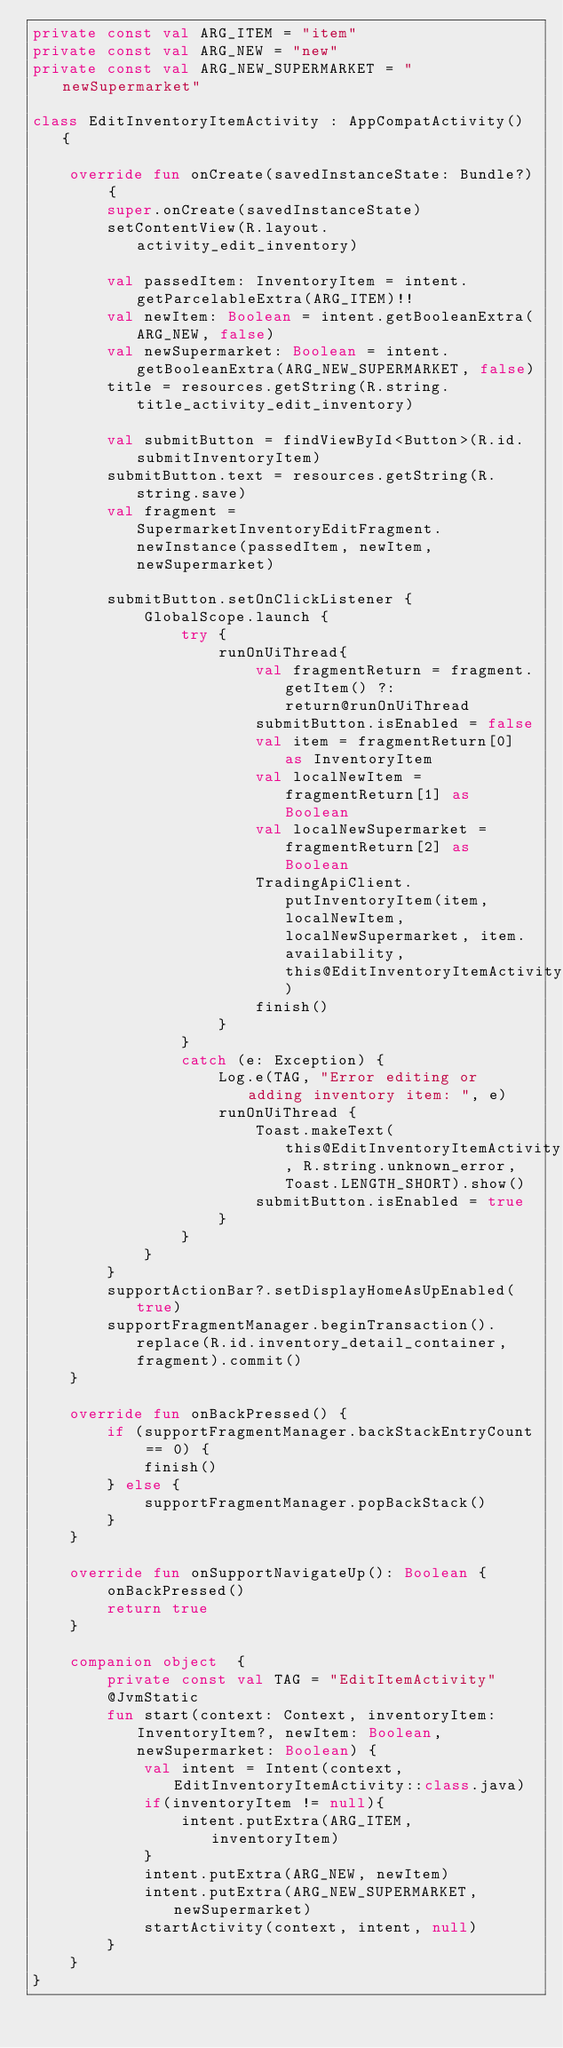Convert code to text. <code><loc_0><loc_0><loc_500><loc_500><_Kotlin_>private const val ARG_ITEM = "item"
private const val ARG_NEW = "new"
private const val ARG_NEW_SUPERMARKET = "newSupermarket"

class EditInventoryItemActivity : AppCompatActivity() {

    override fun onCreate(savedInstanceState: Bundle?) {
        super.onCreate(savedInstanceState)
        setContentView(R.layout.activity_edit_inventory)

        val passedItem: InventoryItem = intent.getParcelableExtra(ARG_ITEM)!!
        val newItem: Boolean = intent.getBooleanExtra(ARG_NEW, false)
        val newSupermarket: Boolean = intent.getBooleanExtra(ARG_NEW_SUPERMARKET, false)
        title = resources.getString(R.string.title_activity_edit_inventory)

        val submitButton = findViewById<Button>(R.id.submitInventoryItem)
        submitButton.text = resources.getString(R.string.save)
        val fragment = SupermarketInventoryEditFragment.newInstance(passedItem, newItem, newSupermarket)

        submitButton.setOnClickListener {
            GlobalScope.launch {
                try {
                    runOnUiThread{
                        val fragmentReturn = fragment.getItem() ?: return@runOnUiThread
                        submitButton.isEnabled = false
                        val item = fragmentReturn[0] as InventoryItem
                        val localNewItem = fragmentReturn[1] as Boolean
                        val localNewSupermarket = fragmentReturn[2] as Boolean
                        TradingApiClient.putInventoryItem(item, localNewItem, localNewSupermarket, item.availability, this@EditInventoryItemActivity)
                        finish()
                    }
                }
                catch (e: Exception) {
                    Log.e(TAG, "Error editing or adding inventory item: ", e)
                    runOnUiThread {
                        Toast.makeText(this@EditInventoryItemActivity, R.string.unknown_error, Toast.LENGTH_SHORT).show()
                        submitButton.isEnabled = true
                    }
                }
            }
        }
        supportActionBar?.setDisplayHomeAsUpEnabled(true)
        supportFragmentManager.beginTransaction().replace(R.id.inventory_detail_container, fragment).commit()
    }

    override fun onBackPressed() {
        if (supportFragmentManager.backStackEntryCount == 0) {
            finish()
        } else {
            supportFragmentManager.popBackStack()
        }
    }

    override fun onSupportNavigateUp(): Boolean {
        onBackPressed()
        return true
    }

    companion object  {
        private const val TAG = "EditItemActivity"
        @JvmStatic
        fun start(context: Context, inventoryItem: InventoryItem?, newItem: Boolean, newSupermarket: Boolean) {
            val intent = Intent(context, EditInventoryItemActivity::class.java)
            if(inventoryItem != null){
                intent.putExtra(ARG_ITEM, inventoryItem)
            }
            intent.putExtra(ARG_NEW, newItem)
            intent.putExtra(ARG_NEW_SUPERMARKET, newSupermarket)
            startActivity(context, intent, null)
        }
    }
}</code> 